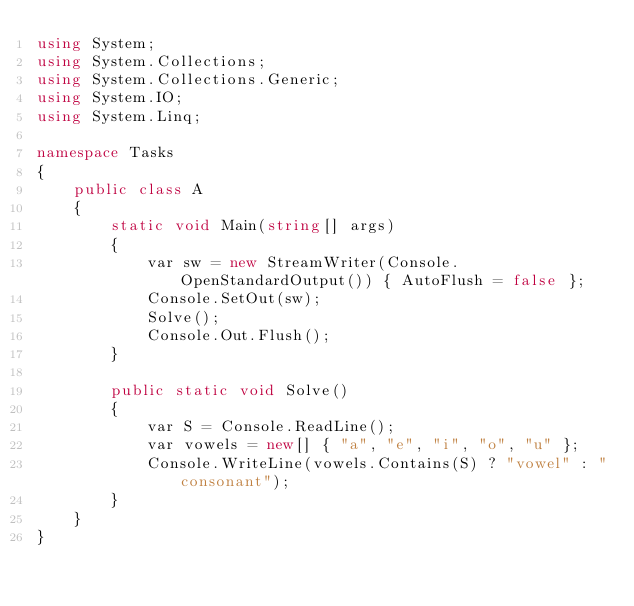<code> <loc_0><loc_0><loc_500><loc_500><_C#_>using System;
using System.Collections;
using System.Collections.Generic;
using System.IO;
using System.Linq;

namespace Tasks
{
    public class A
    {
        static void Main(string[] args)
        {
            var sw = new StreamWriter(Console.OpenStandardOutput()) { AutoFlush = false };
            Console.SetOut(sw);
            Solve();
            Console.Out.Flush();
        }

        public static void Solve()
        {
            var S = Console.ReadLine();
            var vowels = new[] { "a", "e", "i", "o", "u" };
            Console.WriteLine(vowels.Contains(S) ? "vowel" : "consonant");
        }
    }
}
</code> 